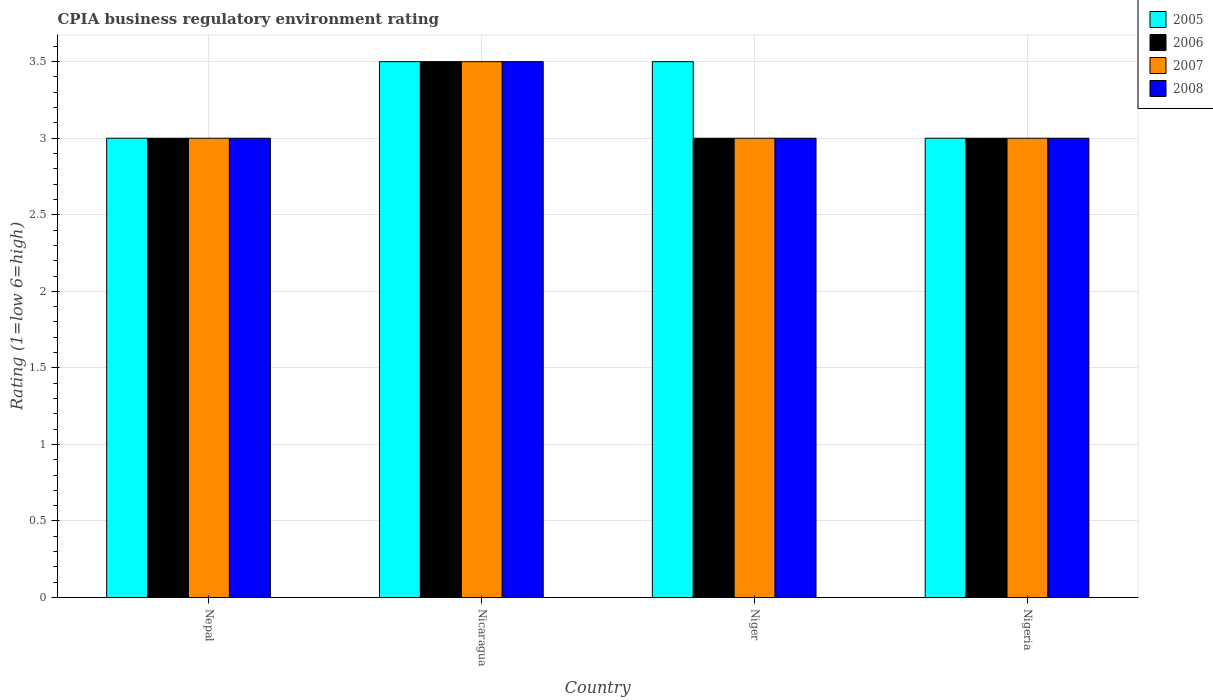How many different coloured bars are there?
Offer a terse response. 4. Are the number of bars on each tick of the X-axis equal?
Ensure brevity in your answer.  Yes. How many bars are there on the 2nd tick from the left?
Provide a short and direct response. 4. What is the label of the 1st group of bars from the left?
Your response must be concise. Nepal. In which country was the CPIA rating in 2006 maximum?
Make the answer very short. Nicaragua. In which country was the CPIA rating in 2007 minimum?
Your answer should be very brief. Nepal. What is the total CPIA rating in 2005 in the graph?
Offer a very short reply. 13. What is the average CPIA rating in 2006 per country?
Give a very brief answer. 3.12. What is the difference between the highest and the second highest CPIA rating in 2008?
Give a very brief answer. -0.5. What is the difference between the highest and the lowest CPIA rating in 2008?
Offer a terse response. 0.5. In how many countries, is the CPIA rating in 2008 greater than the average CPIA rating in 2008 taken over all countries?
Your answer should be very brief. 1. What does the 1st bar from the left in Nigeria represents?
Keep it short and to the point. 2005. Is it the case that in every country, the sum of the CPIA rating in 2006 and CPIA rating in 2007 is greater than the CPIA rating in 2008?
Make the answer very short. Yes. How many bars are there?
Keep it short and to the point. 16. How many countries are there in the graph?
Keep it short and to the point. 4. Are the values on the major ticks of Y-axis written in scientific E-notation?
Provide a succinct answer. No. How many legend labels are there?
Your response must be concise. 4. What is the title of the graph?
Ensure brevity in your answer.  CPIA business regulatory environment rating. Does "1969" appear as one of the legend labels in the graph?
Provide a short and direct response. No. What is the label or title of the X-axis?
Your answer should be very brief. Country. What is the Rating (1=low 6=high) in 2005 in Nepal?
Offer a terse response. 3. What is the Rating (1=low 6=high) in 2007 in Nepal?
Your answer should be compact. 3. What is the Rating (1=low 6=high) of 2008 in Nepal?
Your response must be concise. 3. What is the Rating (1=low 6=high) of 2005 in Nicaragua?
Your answer should be very brief. 3.5. What is the Rating (1=low 6=high) of 2006 in Nicaragua?
Keep it short and to the point. 3.5. What is the Rating (1=low 6=high) of 2005 in Niger?
Provide a short and direct response. 3.5. What is the Rating (1=low 6=high) in 2007 in Niger?
Offer a terse response. 3. What is the Rating (1=low 6=high) of 2008 in Niger?
Your answer should be compact. 3. What is the Rating (1=low 6=high) of 2006 in Nigeria?
Your answer should be very brief. 3. What is the Rating (1=low 6=high) in 2007 in Nigeria?
Your response must be concise. 3. What is the Rating (1=low 6=high) of 2008 in Nigeria?
Give a very brief answer. 3. Across all countries, what is the maximum Rating (1=low 6=high) of 2006?
Your answer should be very brief. 3.5. Across all countries, what is the minimum Rating (1=low 6=high) of 2008?
Your response must be concise. 3. What is the total Rating (1=low 6=high) of 2005 in the graph?
Provide a short and direct response. 13. What is the total Rating (1=low 6=high) in 2006 in the graph?
Your answer should be very brief. 12.5. What is the total Rating (1=low 6=high) of 2007 in the graph?
Your answer should be compact. 12.5. What is the total Rating (1=low 6=high) in 2008 in the graph?
Provide a short and direct response. 12.5. What is the difference between the Rating (1=low 6=high) in 2005 in Nepal and that in Nicaragua?
Offer a very short reply. -0.5. What is the difference between the Rating (1=low 6=high) in 2006 in Nepal and that in Nicaragua?
Your response must be concise. -0.5. What is the difference between the Rating (1=low 6=high) in 2008 in Nepal and that in Nicaragua?
Your answer should be very brief. -0.5. What is the difference between the Rating (1=low 6=high) of 2005 in Nepal and that in Niger?
Provide a succinct answer. -0.5. What is the difference between the Rating (1=low 6=high) of 2006 in Nepal and that in Niger?
Offer a terse response. 0. What is the difference between the Rating (1=low 6=high) in 2005 in Nepal and that in Nigeria?
Provide a short and direct response. 0. What is the difference between the Rating (1=low 6=high) of 2007 in Nepal and that in Nigeria?
Provide a succinct answer. 0. What is the difference between the Rating (1=low 6=high) in 2007 in Nicaragua and that in Niger?
Your answer should be compact. 0.5. What is the difference between the Rating (1=low 6=high) in 2008 in Nicaragua and that in Niger?
Your response must be concise. 0.5. What is the difference between the Rating (1=low 6=high) in 2005 in Nicaragua and that in Nigeria?
Keep it short and to the point. 0.5. What is the difference between the Rating (1=low 6=high) of 2006 in Nicaragua and that in Nigeria?
Your answer should be very brief. 0.5. What is the difference between the Rating (1=low 6=high) of 2007 in Nicaragua and that in Nigeria?
Provide a succinct answer. 0.5. What is the difference between the Rating (1=low 6=high) in 2008 in Nicaragua and that in Nigeria?
Keep it short and to the point. 0.5. What is the difference between the Rating (1=low 6=high) of 2006 in Niger and that in Nigeria?
Your response must be concise. 0. What is the difference between the Rating (1=low 6=high) of 2007 in Niger and that in Nigeria?
Make the answer very short. 0. What is the difference between the Rating (1=low 6=high) in 2008 in Niger and that in Nigeria?
Your answer should be compact. 0. What is the difference between the Rating (1=low 6=high) of 2006 in Nepal and the Rating (1=low 6=high) of 2008 in Nicaragua?
Provide a succinct answer. -0.5. What is the difference between the Rating (1=low 6=high) of 2006 in Nepal and the Rating (1=low 6=high) of 2008 in Niger?
Provide a succinct answer. 0. What is the difference between the Rating (1=low 6=high) of 2007 in Nepal and the Rating (1=low 6=high) of 2008 in Niger?
Offer a terse response. 0. What is the difference between the Rating (1=low 6=high) of 2005 in Nicaragua and the Rating (1=low 6=high) of 2007 in Niger?
Ensure brevity in your answer.  0.5. What is the difference between the Rating (1=low 6=high) of 2007 in Nicaragua and the Rating (1=low 6=high) of 2008 in Niger?
Your answer should be very brief. 0.5. What is the difference between the Rating (1=low 6=high) in 2005 in Nicaragua and the Rating (1=low 6=high) in 2007 in Nigeria?
Provide a short and direct response. 0.5. What is the difference between the Rating (1=low 6=high) of 2005 in Nicaragua and the Rating (1=low 6=high) of 2008 in Nigeria?
Your response must be concise. 0.5. What is the difference between the Rating (1=low 6=high) in 2007 in Nicaragua and the Rating (1=low 6=high) in 2008 in Nigeria?
Ensure brevity in your answer.  0.5. What is the difference between the Rating (1=low 6=high) in 2005 in Niger and the Rating (1=low 6=high) in 2006 in Nigeria?
Keep it short and to the point. 0.5. What is the difference between the Rating (1=low 6=high) of 2006 in Niger and the Rating (1=low 6=high) of 2007 in Nigeria?
Your response must be concise. 0. What is the difference between the Rating (1=low 6=high) of 2006 in Niger and the Rating (1=low 6=high) of 2008 in Nigeria?
Your answer should be very brief. 0. What is the difference between the Rating (1=low 6=high) of 2007 in Niger and the Rating (1=low 6=high) of 2008 in Nigeria?
Offer a very short reply. 0. What is the average Rating (1=low 6=high) in 2005 per country?
Ensure brevity in your answer.  3.25. What is the average Rating (1=low 6=high) in 2006 per country?
Your answer should be compact. 3.12. What is the average Rating (1=low 6=high) in 2007 per country?
Ensure brevity in your answer.  3.12. What is the average Rating (1=low 6=high) of 2008 per country?
Ensure brevity in your answer.  3.12. What is the difference between the Rating (1=low 6=high) of 2005 and Rating (1=low 6=high) of 2006 in Nepal?
Give a very brief answer. 0. What is the difference between the Rating (1=low 6=high) of 2006 and Rating (1=low 6=high) of 2007 in Nepal?
Give a very brief answer. 0. What is the difference between the Rating (1=low 6=high) of 2006 and Rating (1=low 6=high) of 2008 in Nepal?
Offer a terse response. 0. What is the difference between the Rating (1=low 6=high) in 2006 and Rating (1=low 6=high) in 2007 in Nicaragua?
Provide a short and direct response. 0. What is the difference between the Rating (1=low 6=high) in 2007 and Rating (1=low 6=high) in 2008 in Nicaragua?
Make the answer very short. 0. What is the difference between the Rating (1=low 6=high) in 2005 and Rating (1=low 6=high) in 2006 in Niger?
Offer a terse response. 0.5. What is the difference between the Rating (1=low 6=high) of 2005 and Rating (1=low 6=high) of 2007 in Niger?
Your answer should be compact. 0.5. What is the difference between the Rating (1=low 6=high) of 2005 and Rating (1=low 6=high) of 2008 in Niger?
Provide a short and direct response. 0.5. What is the difference between the Rating (1=low 6=high) of 2006 and Rating (1=low 6=high) of 2007 in Niger?
Ensure brevity in your answer.  0. What is the difference between the Rating (1=low 6=high) of 2006 and Rating (1=low 6=high) of 2008 in Niger?
Offer a terse response. 0. What is the difference between the Rating (1=low 6=high) of 2007 and Rating (1=low 6=high) of 2008 in Niger?
Keep it short and to the point. 0. What is the difference between the Rating (1=low 6=high) of 2005 and Rating (1=low 6=high) of 2006 in Nigeria?
Provide a succinct answer. 0. What is the difference between the Rating (1=low 6=high) of 2007 and Rating (1=low 6=high) of 2008 in Nigeria?
Provide a short and direct response. 0. What is the ratio of the Rating (1=low 6=high) of 2007 in Nepal to that in Nicaragua?
Provide a succinct answer. 0.86. What is the ratio of the Rating (1=low 6=high) in 2005 in Nepal to that in Niger?
Provide a short and direct response. 0.86. What is the ratio of the Rating (1=low 6=high) in 2006 in Nepal to that in Niger?
Offer a very short reply. 1. What is the ratio of the Rating (1=low 6=high) of 2007 in Nepal to that in Niger?
Ensure brevity in your answer.  1. What is the ratio of the Rating (1=low 6=high) of 2008 in Nepal to that in Niger?
Give a very brief answer. 1. What is the ratio of the Rating (1=low 6=high) of 2005 in Nepal to that in Nigeria?
Your answer should be very brief. 1. What is the ratio of the Rating (1=low 6=high) in 2006 in Nepal to that in Nigeria?
Offer a very short reply. 1. What is the ratio of the Rating (1=low 6=high) of 2008 in Nepal to that in Nigeria?
Provide a succinct answer. 1. What is the ratio of the Rating (1=low 6=high) of 2005 in Nicaragua to that in Nigeria?
Your response must be concise. 1.17. What is the ratio of the Rating (1=low 6=high) of 2008 in Nicaragua to that in Nigeria?
Offer a terse response. 1.17. What is the ratio of the Rating (1=low 6=high) in 2005 in Niger to that in Nigeria?
Offer a terse response. 1.17. What is the ratio of the Rating (1=low 6=high) in 2007 in Niger to that in Nigeria?
Offer a terse response. 1. What is the difference between the highest and the second highest Rating (1=low 6=high) of 2006?
Ensure brevity in your answer.  0.5. What is the difference between the highest and the second highest Rating (1=low 6=high) in 2007?
Your answer should be compact. 0.5. What is the difference between the highest and the second highest Rating (1=low 6=high) of 2008?
Your answer should be compact. 0.5. What is the difference between the highest and the lowest Rating (1=low 6=high) in 2005?
Make the answer very short. 0.5. What is the difference between the highest and the lowest Rating (1=low 6=high) in 2006?
Your response must be concise. 0.5. What is the difference between the highest and the lowest Rating (1=low 6=high) of 2007?
Your answer should be very brief. 0.5. 